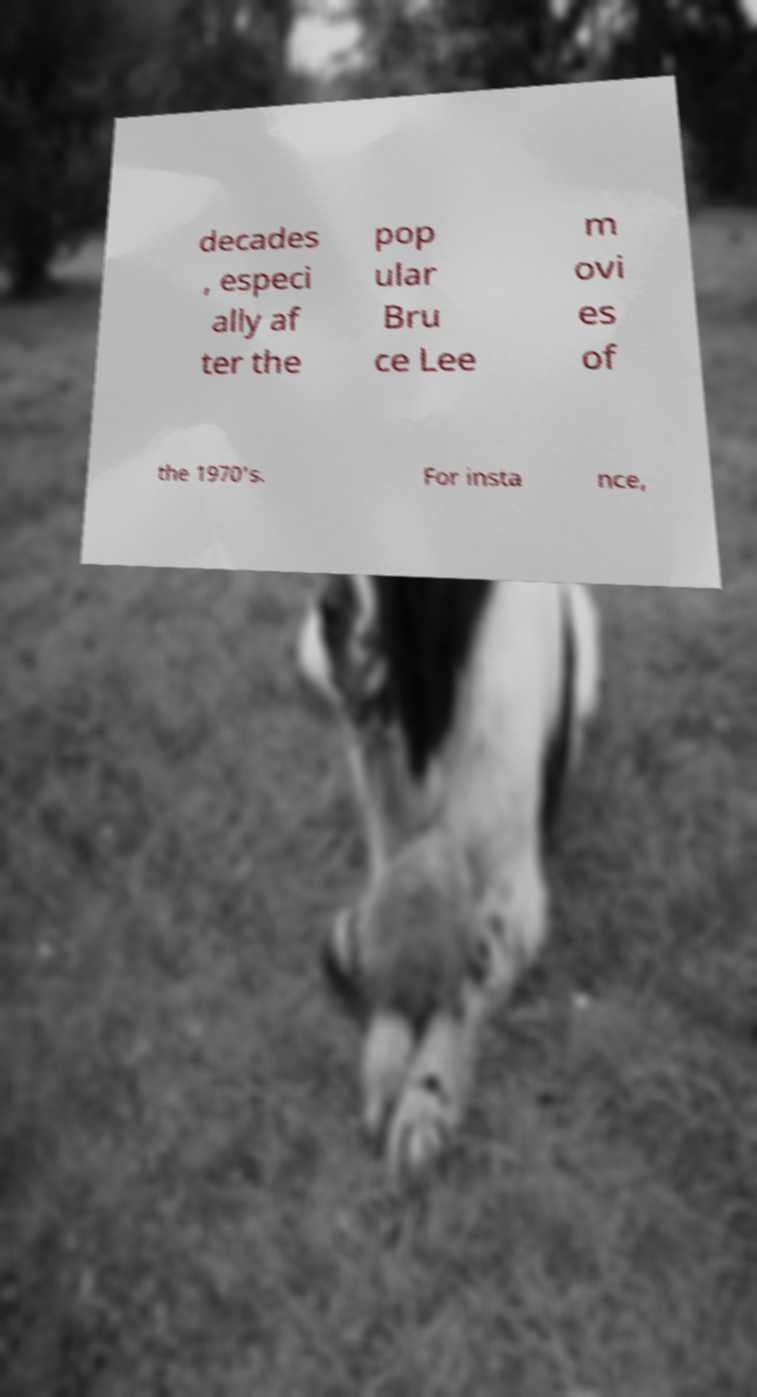Could you assist in decoding the text presented in this image and type it out clearly? decades , especi ally af ter the pop ular Bru ce Lee m ovi es of the 1970's. For insta nce, 